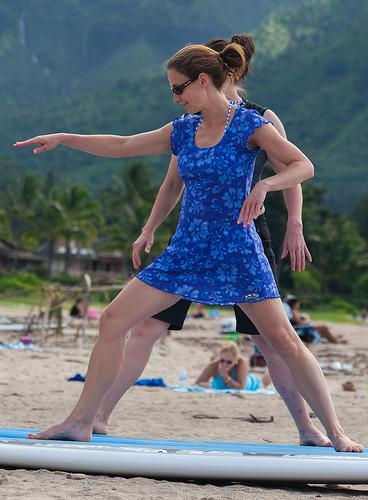Provide a vivid description of the image's primary subject and their posture. A woman with her hair tied back is practicing balance on a surfboard placed on the beach. She wears a blue floral dress and maintains focus with her arms extended to her sides. Illustrate the main subject's appearance and their present occupation in the image. The woman, dressed in a blue floral dress with her hair neatly tied back, is seen practicing surfing techniques on a surfboard on the sand, focusing intently as she balances with her arms outstretched. Present a captivating image of the key subject and their current engagement. A focused woman in a blue floral dress practices her surfing stance on a stationary surfboard on the beach, her arms extended for balance. Portray the main figure and the action they're undertaking in an engaging manner. A woman in a blue dress is captured practicing her surf stance on a surfboard on the beach, her arms spread wide for balance, against a backdrop of beachgoers and lush mountains. Depict the central theme of the image and the subject's ongoing movement. A woman in a blue floral dress is actively practicing her balance on a surfboard on the beach, her arms held out to the sides, surrounded by a scenic beach setting. Elaborate on the main subject and its surroundings in the image. A woman wearing a blue floral dress is balancing on a surfboard on the beach, her arms extended, with the beach and mountains in the background. Describe the image's chief subject and the activity they are performing. A woman with her hair in a ponytail, dressed in a blue floral dress, is practicing balancing on a surfboard on the beach, extending her arms for stability. Mention the primary focus of the image and their current action. A woman in a blue dress is practicing her balance on a surfboard on the beach, extending her arms to the sides to maintain stability. Highlight the central figure of the image and their activity. A woman in a blue floral dress is focused on balancing on a surfboard on the beach, with her arms outstretched to aid her stability. Narrate the prime focus of the image and their dynamic action. A woman in a blue dress practices balancing on a surfboard on the beach, her arms extended to the sides, amidst a scenic beach environment. 